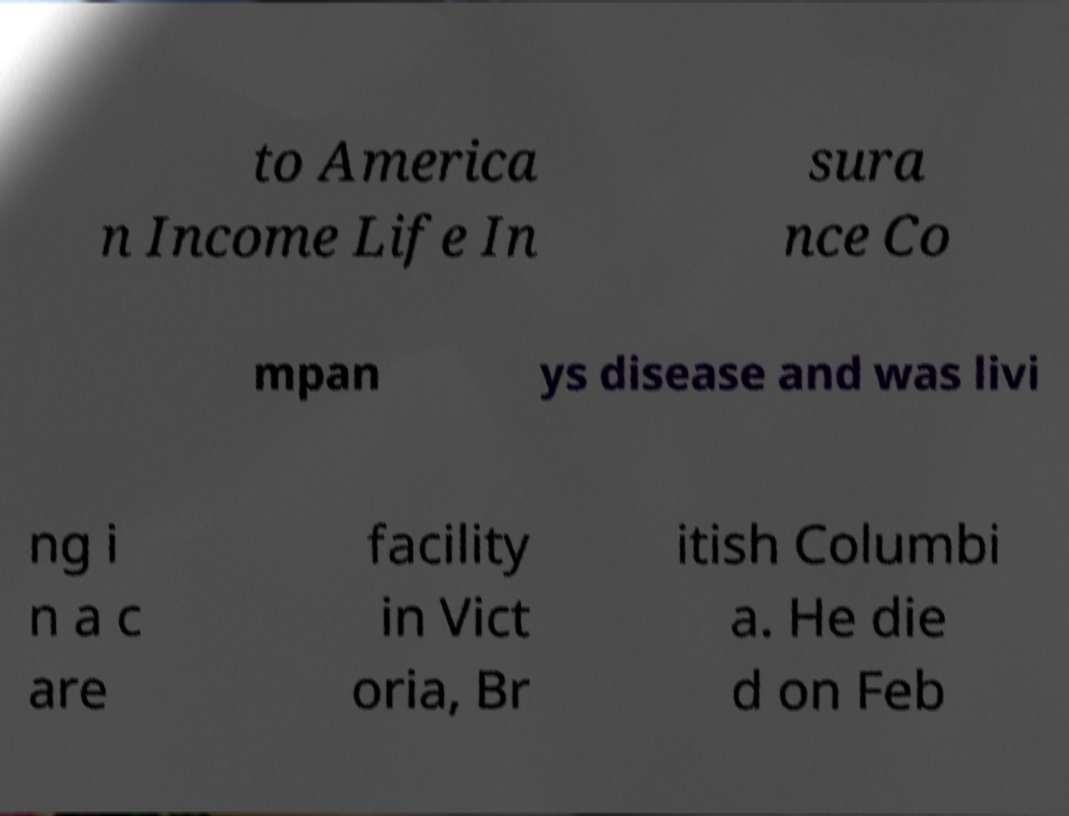For documentation purposes, I need the text within this image transcribed. Could you provide that? to America n Income Life In sura nce Co mpan ys disease and was livi ng i n a c are facility in Vict oria, Br itish Columbi a. He die d on Feb 